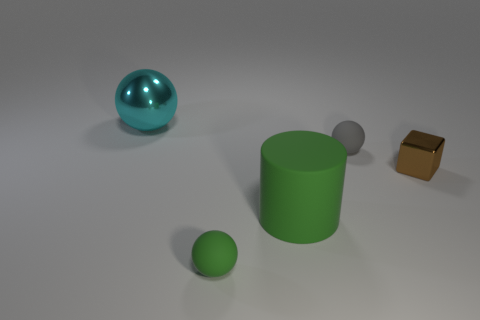What color is the tiny sphere that is in front of the metallic thing that is on the right side of the big thing that is on the left side of the tiny green thing? The tiny sphere in front of the metallic object to the right of the large cylinder and to the left of the small green sphere is silver in color, displaying a reflective surface that contrasts with the surrounding objects. 